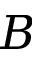<formula> <loc_0><loc_0><loc_500><loc_500>B</formula> 